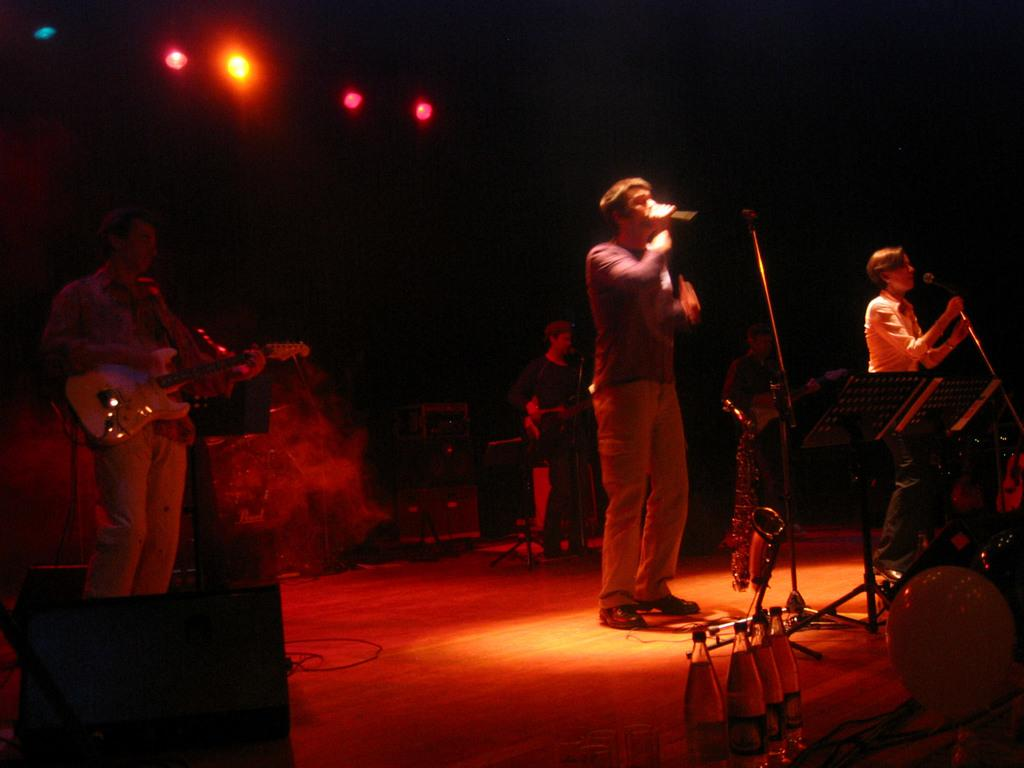What are the two people in the image doing? The two people in the image are singing. How are the singers amplifying their voices in the image? The singers are using a microphone. What instruments are being played by the musicians in the image? There are three men playing guitar in the image. What can be seen on the stage or dais in the image? There are water bottles visible on a dais or stage. What type of steel is used to make the question visible in the image? There is no question visible in the image, and therefore no steel is involved. 